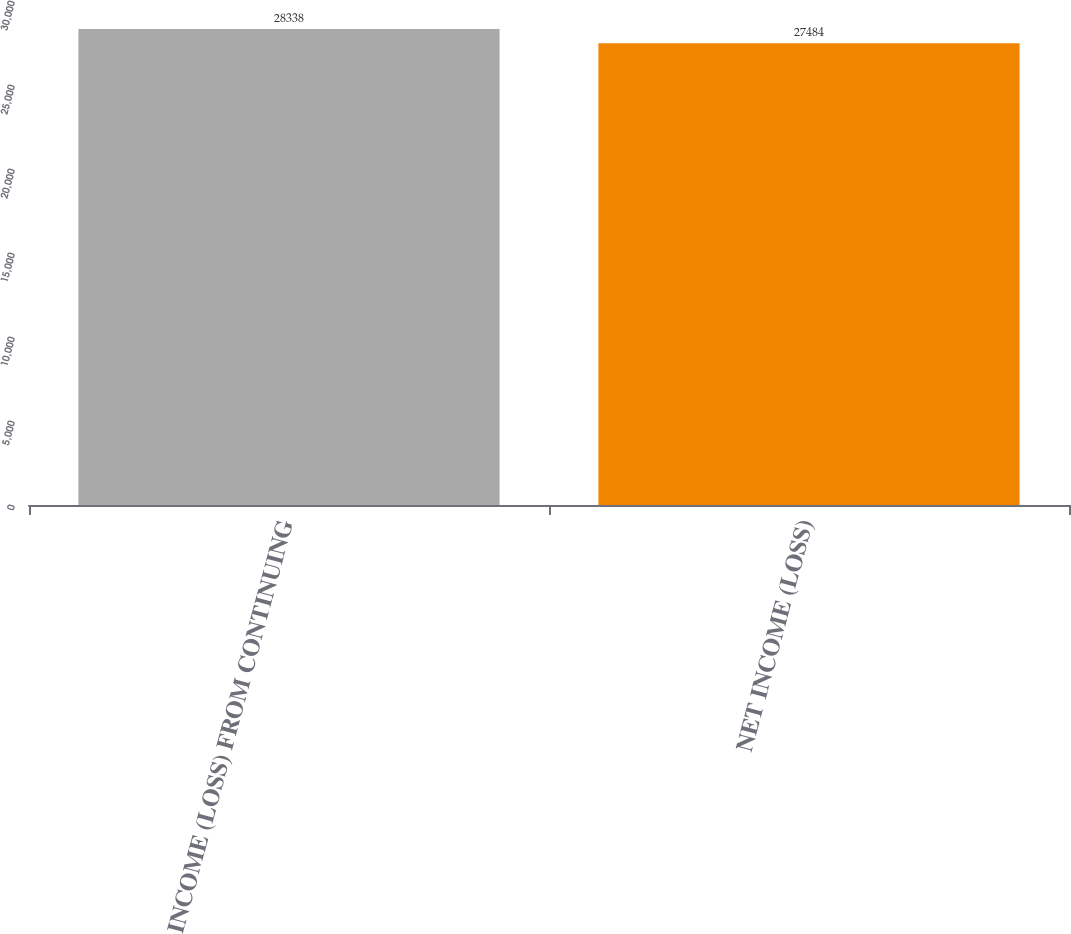Convert chart. <chart><loc_0><loc_0><loc_500><loc_500><bar_chart><fcel>INCOME (LOSS) FROM CONTINUING<fcel>NET INCOME (LOSS)<nl><fcel>28338<fcel>27484<nl></chart> 